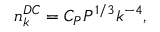Convert formula to latex. <formula><loc_0><loc_0><loc_500><loc_500>n _ { k } ^ { D C } = C _ { P } P ^ { 1 / 3 } k ^ { - 4 } ,</formula> 